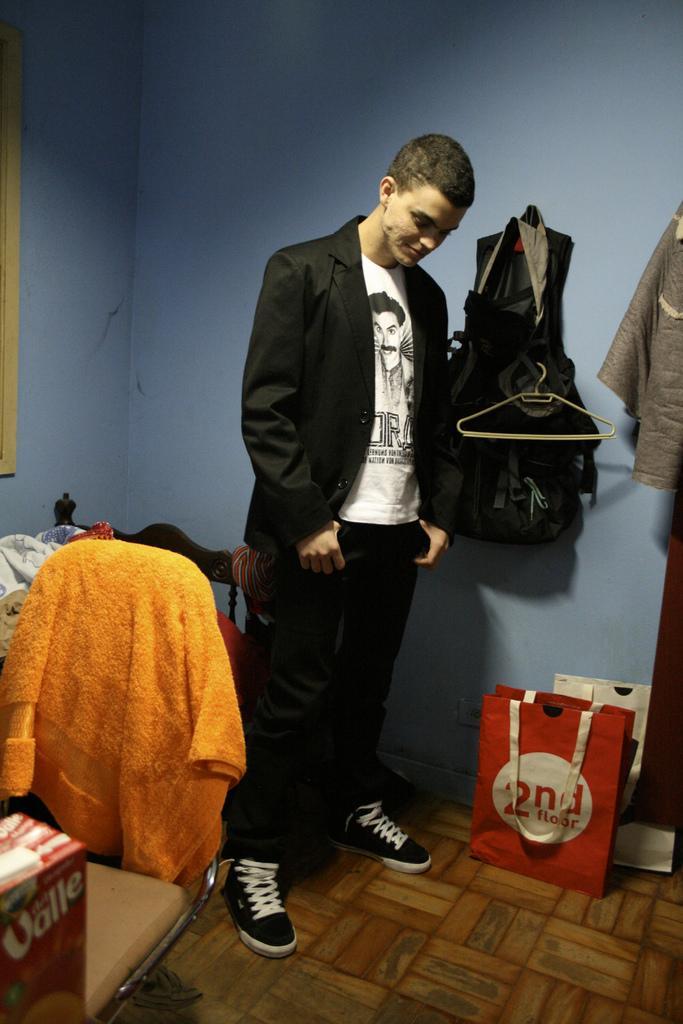In one or two sentences, can you explain what this image depicts? In this image in the center there is one man who is standing, and on the left side there is one chair. On the chair there are some clothes, on the right side there are some bags and at the bottom there is a floor and some boxes. In the background there is a wall and some clothes and bags are hanging. 